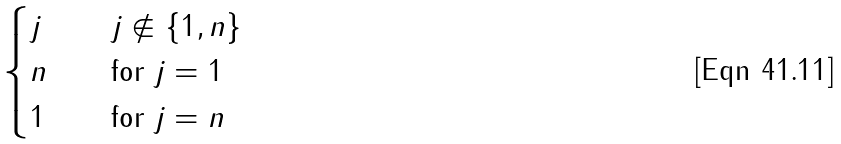<formula> <loc_0><loc_0><loc_500><loc_500>\begin{cases} j & \quad j \not \in \{ 1 , n \} \\ n & \quad \text {for} \ j = 1 \\ 1 & \quad \text {for} \ j = n \end{cases}</formula> 